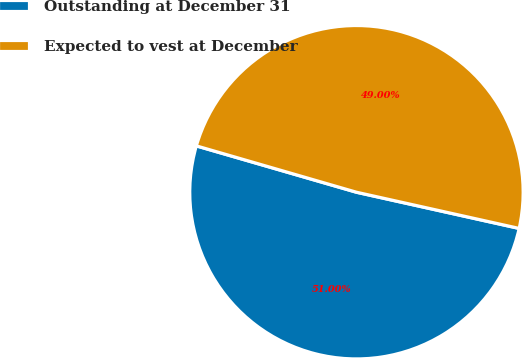Convert chart to OTSL. <chart><loc_0><loc_0><loc_500><loc_500><pie_chart><fcel>Outstanding at December 31<fcel>Expected to vest at December<nl><fcel>51.0%<fcel>49.0%<nl></chart> 